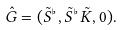Convert formula to latex. <formula><loc_0><loc_0><loc_500><loc_500>\hat { G } = ( \tilde { S } ^ { \flat } , \tilde { S } ^ { \flat } \tilde { K } , 0 ) .</formula> 